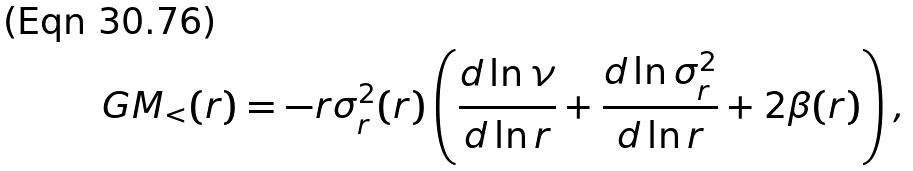Convert formula to latex. <formula><loc_0><loc_0><loc_500><loc_500>G M _ { < } ( r ) = - r \sigma _ { r } ^ { 2 } ( r ) \left ( \frac { d \ln \nu } { d \ln r } + \frac { d \ln \sigma _ { r } ^ { 2 } } { d \ln r } + 2 \beta ( r ) \right ) ,</formula> 